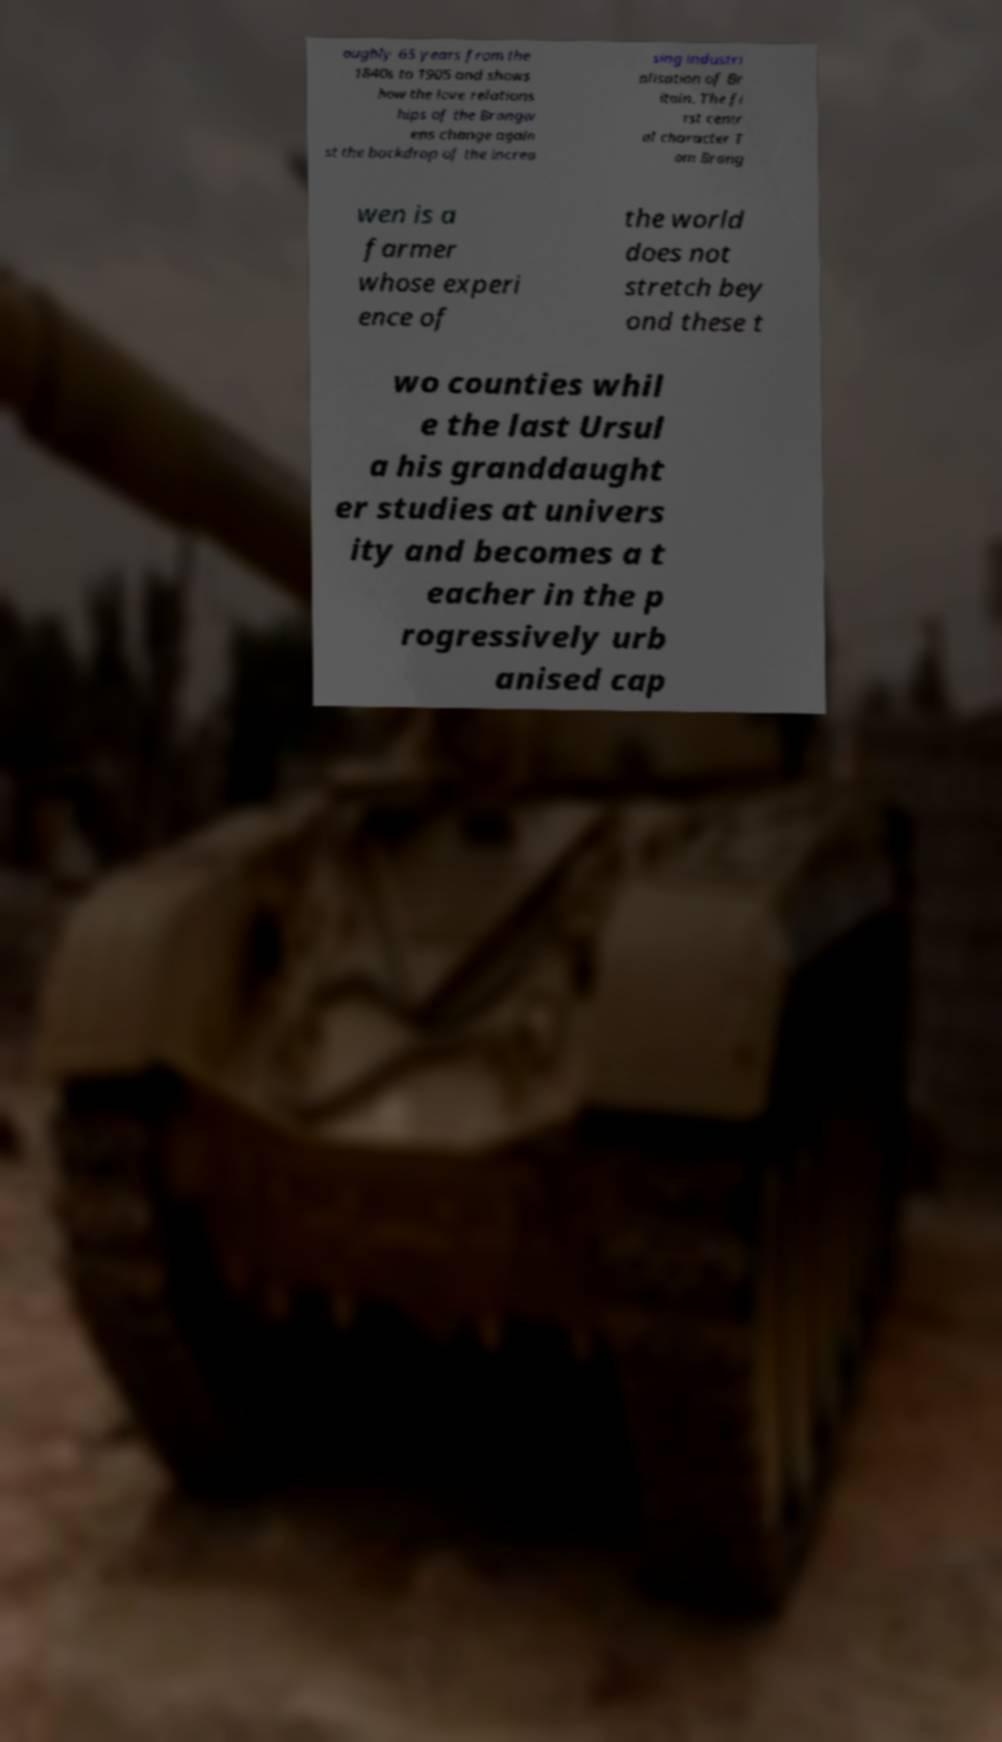There's text embedded in this image that I need extracted. Can you transcribe it verbatim? oughly 65 years from the 1840s to 1905 and shows how the love relations hips of the Brangw ens change again st the backdrop of the increa sing industri alisation of Br itain. The fi rst centr al character T om Brang wen is a farmer whose experi ence of the world does not stretch bey ond these t wo counties whil e the last Ursul a his granddaught er studies at univers ity and becomes a t eacher in the p rogressively urb anised cap 